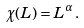Convert formula to latex. <formula><loc_0><loc_0><loc_500><loc_500>\chi ( L ) = L ^ { \alpha } \, .</formula> 